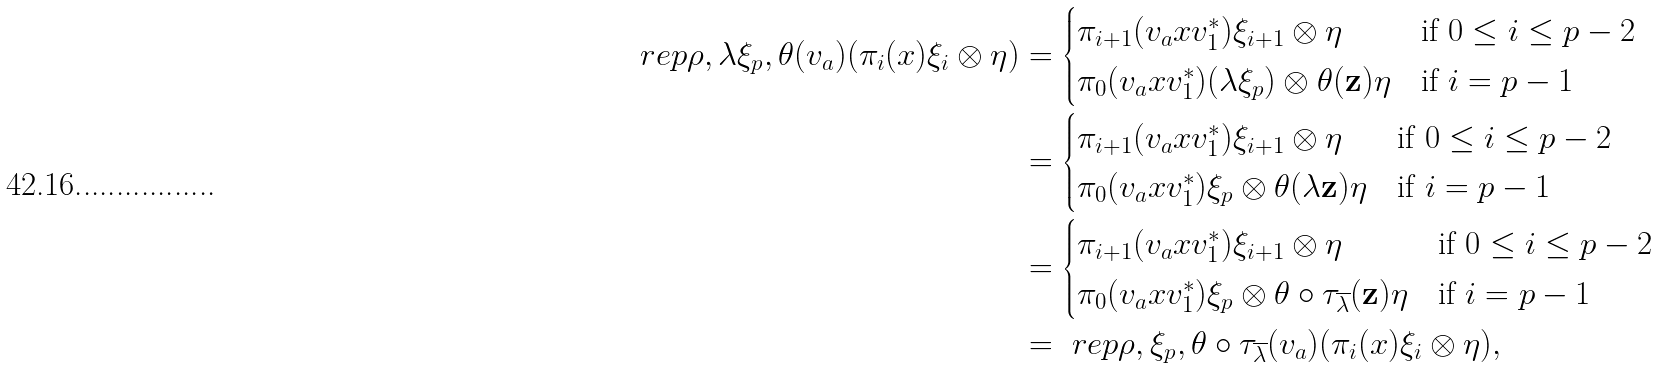Convert formula to latex. <formula><loc_0><loc_0><loc_500><loc_500>\ r e p { \rho , \lambda \xi _ { p } , \theta } ( v _ { a } ) ( \pi _ { i } ( x ) \xi _ { i } \otimes \eta ) & = \begin{cases} \pi _ { i + 1 } ( v _ { a } x v _ { 1 } ^ { * } ) \xi _ { i + 1 } \otimes \eta & \text {if $0 \leq i \leq p-2$} \\ \pi _ { 0 } ( v _ { a } x v _ { 1 } ^ { * } ) ( \lambda \xi _ { p } ) \otimes \theta ( \mathbf z ) \eta & \text {if $i = p-1$} \end{cases} \\ & = \begin{cases} \pi _ { i + 1 } ( v _ { a } x v _ { 1 } ^ { * } ) \xi _ { i + 1 } \otimes \eta & \text {if $0 \leq i \leq p-2$} \\ \pi _ { 0 } ( v _ { a } x v _ { 1 } ^ { * } ) \xi _ { p } \otimes \theta ( \lambda \mathbf z ) \eta & \text {if $i = p-1$} \end{cases} \\ & = \begin{cases} \pi _ { i + 1 } ( v _ { a } x v _ { 1 } ^ { * } ) \xi _ { i + 1 } \otimes \eta & \text {if $0 \leq i \leq p-2$} \\ \pi _ { 0 } ( v _ { a } x v _ { 1 } ^ { * } ) \xi _ { p } \otimes \theta \circ \tau _ { \overline { \lambda } } ( \mathbf z ) \eta & \text {if $i = p-1$} \end{cases} \\ & = \ r e p { \rho , \xi _ { p } , \theta \circ \tau _ { \overline { \lambda } } } ( v _ { a } ) ( \pi _ { i } ( x ) \xi _ { i } \otimes \eta ) ,</formula> 